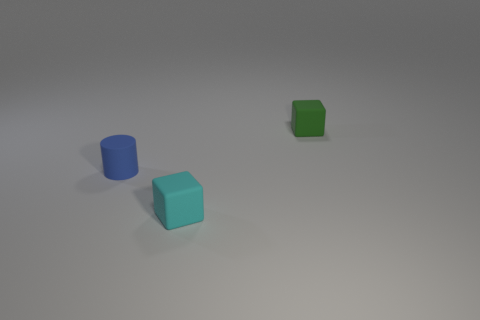Add 2 matte blocks. How many objects exist? 5 Subtract all blocks. How many objects are left? 1 Subtract all small blue objects. Subtract all small shiny spheres. How many objects are left? 2 Add 3 blue cylinders. How many blue cylinders are left? 4 Add 1 tiny green things. How many tiny green things exist? 2 Subtract 0 gray cylinders. How many objects are left? 3 